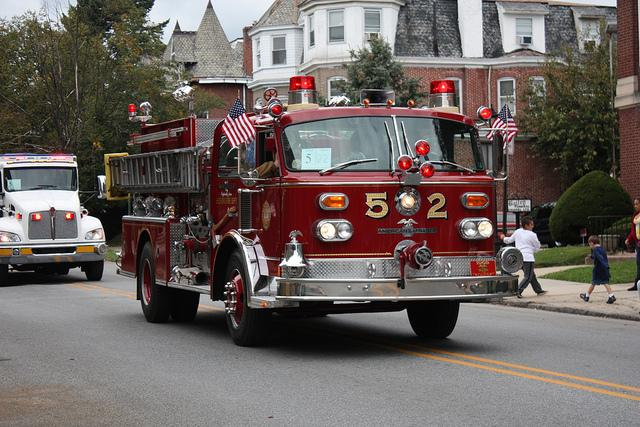What country's flag can be seen on the truck? Please explain your reasoning. america. United states is red white and blue stripes with the stars. 